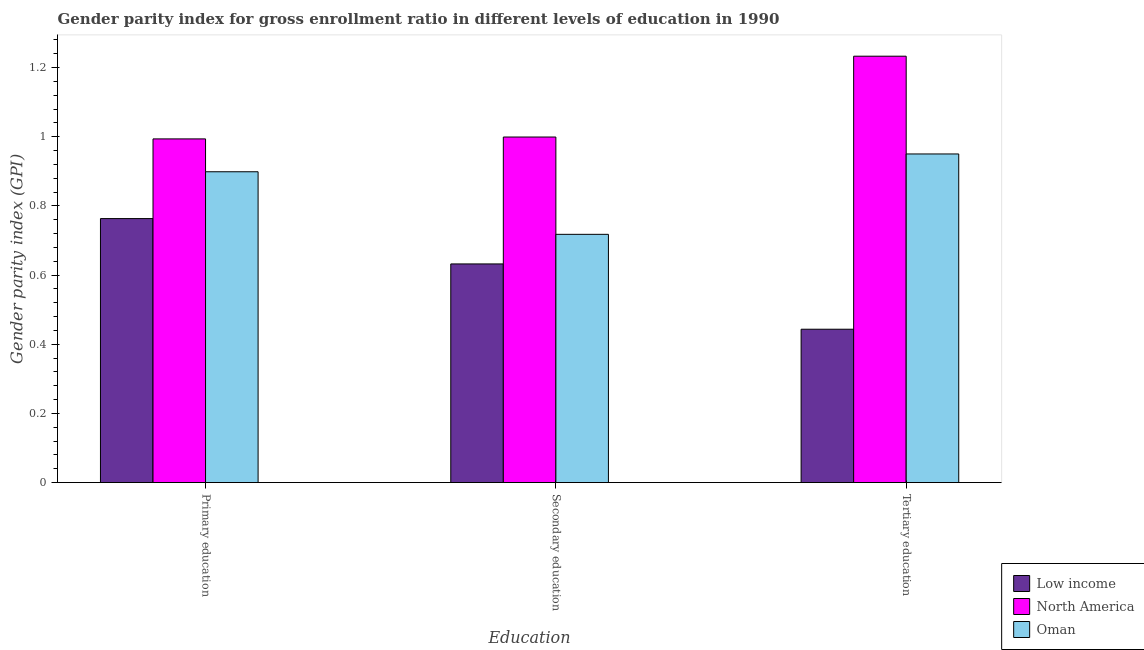How many bars are there on the 1st tick from the left?
Provide a short and direct response. 3. What is the label of the 1st group of bars from the left?
Your response must be concise. Primary education. What is the gender parity index in primary education in Low income?
Offer a very short reply. 0.76. Across all countries, what is the maximum gender parity index in secondary education?
Offer a terse response. 1. Across all countries, what is the minimum gender parity index in tertiary education?
Provide a succinct answer. 0.44. In which country was the gender parity index in tertiary education maximum?
Your answer should be compact. North America. What is the total gender parity index in primary education in the graph?
Ensure brevity in your answer.  2.66. What is the difference between the gender parity index in primary education in Low income and that in North America?
Make the answer very short. -0.23. What is the difference between the gender parity index in primary education in Low income and the gender parity index in tertiary education in North America?
Provide a succinct answer. -0.47. What is the average gender parity index in tertiary education per country?
Your response must be concise. 0.88. What is the difference between the gender parity index in secondary education and gender parity index in tertiary education in Oman?
Make the answer very short. -0.23. In how many countries, is the gender parity index in secondary education greater than 0.6000000000000001 ?
Ensure brevity in your answer.  3. What is the ratio of the gender parity index in tertiary education in North America to that in Low income?
Offer a very short reply. 2.78. What is the difference between the highest and the second highest gender parity index in secondary education?
Your answer should be very brief. 0.28. What is the difference between the highest and the lowest gender parity index in secondary education?
Your response must be concise. 0.37. What does the 1st bar from the left in Primary education represents?
Offer a terse response. Low income. What does the 3rd bar from the right in Secondary education represents?
Your response must be concise. Low income. How many bars are there?
Your answer should be compact. 9. Are all the bars in the graph horizontal?
Provide a succinct answer. No. How many countries are there in the graph?
Your response must be concise. 3. What is the difference between two consecutive major ticks on the Y-axis?
Make the answer very short. 0.2. Are the values on the major ticks of Y-axis written in scientific E-notation?
Your response must be concise. No. Does the graph contain any zero values?
Make the answer very short. No. Where does the legend appear in the graph?
Provide a short and direct response. Bottom right. How many legend labels are there?
Offer a terse response. 3. How are the legend labels stacked?
Your answer should be very brief. Vertical. What is the title of the graph?
Ensure brevity in your answer.  Gender parity index for gross enrollment ratio in different levels of education in 1990. What is the label or title of the X-axis?
Your answer should be compact. Education. What is the label or title of the Y-axis?
Keep it short and to the point. Gender parity index (GPI). What is the Gender parity index (GPI) of Low income in Primary education?
Provide a succinct answer. 0.76. What is the Gender parity index (GPI) of North America in Primary education?
Your answer should be very brief. 0.99. What is the Gender parity index (GPI) in Oman in Primary education?
Your answer should be very brief. 0.9. What is the Gender parity index (GPI) of Low income in Secondary education?
Offer a terse response. 0.63. What is the Gender parity index (GPI) of North America in Secondary education?
Provide a short and direct response. 1. What is the Gender parity index (GPI) in Oman in Secondary education?
Provide a succinct answer. 0.72. What is the Gender parity index (GPI) of Low income in Tertiary education?
Give a very brief answer. 0.44. What is the Gender parity index (GPI) in North America in Tertiary education?
Provide a short and direct response. 1.23. What is the Gender parity index (GPI) of Oman in Tertiary education?
Your response must be concise. 0.95. Across all Education, what is the maximum Gender parity index (GPI) of Low income?
Your answer should be compact. 0.76. Across all Education, what is the maximum Gender parity index (GPI) of North America?
Ensure brevity in your answer.  1.23. Across all Education, what is the maximum Gender parity index (GPI) of Oman?
Keep it short and to the point. 0.95. Across all Education, what is the minimum Gender parity index (GPI) of Low income?
Offer a very short reply. 0.44. Across all Education, what is the minimum Gender parity index (GPI) in North America?
Offer a terse response. 0.99. Across all Education, what is the minimum Gender parity index (GPI) in Oman?
Offer a very short reply. 0.72. What is the total Gender parity index (GPI) of Low income in the graph?
Ensure brevity in your answer.  1.84. What is the total Gender parity index (GPI) in North America in the graph?
Your answer should be very brief. 3.23. What is the total Gender parity index (GPI) of Oman in the graph?
Your answer should be compact. 2.57. What is the difference between the Gender parity index (GPI) of Low income in Primary education and that in Secondary education?
Offer a terse response. 0.13. What is the difference between the Gender parity index (GPI) of North America in Primary education and that in Secondary education?
Your response must be concise. -0.01. What is the difference between the Gender parity index (GPI) of Oman in Primary education and that in Secondary education?
Offer a terse response. 0.18. What is the difference between the Gender parity index (GPI) in Low income in Primary education and that in Tertiary education?
Give a very brief answer. 0.32. What is the difference between the Gender parity index (GPI) of North America in Primary education and that in Tertiary education?
Your answer should be compact. -0.24. What is the difference between the Gender parity index (GPI) of Oman in Primary education and that in Tertiary education?
Keep it short and to the point. -0.05. What is the difference between the Gender parity index (GPI) in Low income in Secondary education and that in Tertiary education?
Your response must be concise. 0.19. What is the difference between the Gender parity index (GPI) in North America in Secondary education and that in Tertiary education?
Offer a terse response. -0.23. What is the difference between the Gender parity index (GPI) of Oman in Secondary education and that in Tertiary education?
Provide a succinct answer. -0.23. What is the difference between the Gender parity index (GPI) of Low income in Primary education and the Gender parity index (GPI) of North America in Secondary education?
Keep it short and to the point. -0.24. What is the difference between the Gender parity index (GPI) of Low income in Primary education and the Gender parity index (GPI) of Oman in Secondary education?
Provide a short and direct response. 0.05. What is the difference between the Gender parity index (GPI) in North America in Primary education and the Gender parity index (GPI) in Oman in Secondary education?
Your answer should be compact. 0.28. What is the difference between the Gender parity index (GPI) in Low income in Primary education and the Gender parity index (GPI) in North America in Tertiary education?
Provide a short and direct response. -0.47. What is the difference between the Gender parity index (GPI) in Low income in Primary education and the Gender parity index (GPI) in Oman in Tertiary education?
Your answer should be compact. -0.19. What is the difference between the Gender parity index (GPI) in North America in Primary education and the Gender parity index (GPI) in Oman in Tertiary education?
Your answer should be compact. 0.04. What is the difference between the Gender parity index (GPI) of Low income in Secondary education and the Gender parity index (GPI) of North America in Tertiary education?
Offer a very short reply. -0.6. What is the difference between the Gender parity index (GPI) of Low income in Secondary education and the Gender parity index (GPI) of Oman in Tertiary education?
Your answer should be very brief. -0.32. What is the difference between the Gender parity index (GPI) in North America in Secondary education and the Gender parity index (GPI) in Oman in Tertiary education?
Ensure brevity in your answer.  0.05. What is the average Gender parity index (GPI) in Low income per Education?
Your response must be concise. 0.61. What is the average Gender parity index (GPI) of North America per Education?
Provide a succinct answer. 1.08. What is the average Gender parity index (GPI) of Oman per Education?
Provide a short and direct response. 0.86. What is the difference between the Gender parity index (GPI) in Low income and Gender parity index (GPI) in North America in Primary education?
Your answer should be very brief. -0.23. What is the difference between the Gender parity index (GPI) in Low income and Gender parity index (GPI) in Oman in Primary education?
Make the answer very short. -0.14. What is the difference between the Gender parity index (GPI) of North America and Gender parity index (GPI) of Oman in Primary education?
Offer a very short reply. 0.1. What is the difference between the Gender parity index (GPI) in Low income and Gender parity index (GPI) in North America in Secondary education?
Offer a terse response. -0.37. What is the difference between the Gender parity index (GPI) in Low income and Gender parity index (GPI) in Oman in Secondary education?
Provide a short and direct response. -0.09. What is the difference between the Gender parity index (GPI) of North America and Gender parity index (GPI) of Oman in Secondary education?
Keep it short and to the point. 0.28. What is the difference between the Gender parity index (GPI) in Low income and Gender parity index (GPI) in North America in Tertiary education?
Ensure brevity in your answer.  -0.79. What is the difference between the Gender parity index (GPI) of Low income and Gender parity index (GPI) of Oman in Tertiary education?
Make the answer very short. -0.51. What is the difference between the Gender parity index (GPI) in North America and Gender parity index (GPI) in Oman in Tertiary education?
Your answer should be compact. 0.28. What is the ratio of the Gender parity index (GPI) in Low income in Primary education to that in Secondary education?
Your response must be concise. 1.21. What is the ratio of the Gender parity index (GPI) in Oman in Primary education to that in Secondary education?
Make the answer very short. 1.25. What is the ratio of the Gender parity index (GPI) in Low income in Primary education to that in Tertiary education?
Offer a very short reply. 1.72. What is the ratio of the Gender parity index (GPI) of North America in Primary education to that in Tertiary education?
Ensure brevity in your answer.  0.81. What is the ratio of the Gender parity index (GPI) in Oman in Primary education to that in Tertiary education?
Offer a terse response. 0.95. What is the ratio of the Gender parity index (GPI) of Low income in Secondary education to that in Tertiary education?
Keep it short and to the point. 1.43. What is the ratio of the Gender parity index (GPI) of North America in Secondary education to that in Tertiary education?
Keep it short and to the point. 0.81. What is the ratio of the Gender parity index (GPI) of Oman in Secondary education to that in Tertiary education?
Your response must be concise. 0.76. What is the difference between the highest and the second highest Gender parity index (GPI) in Low income?
Make the answer very short. 0.13. What is the difference between the highest and the second highest Gender parity index (GPI) of North America?
Give a very brief answer. 0.23. What is the difference between the highest and the second highest Gender parity index (GPI) in Oman?
Keep it short and to the point. 0.05. What is the difference between the highest and the lowest Gender parity index (GPI) in Low income?
Provide a succinct answer. 0.32. What is the difference between the highest and the lowest Gender parity index (GPI) of North America?
Provide a short and direct response. 0.24. What is the difference between the highest and the lowest Gender parity index (GPI) of Oman?
Your answer should be very brief. 0.23. 